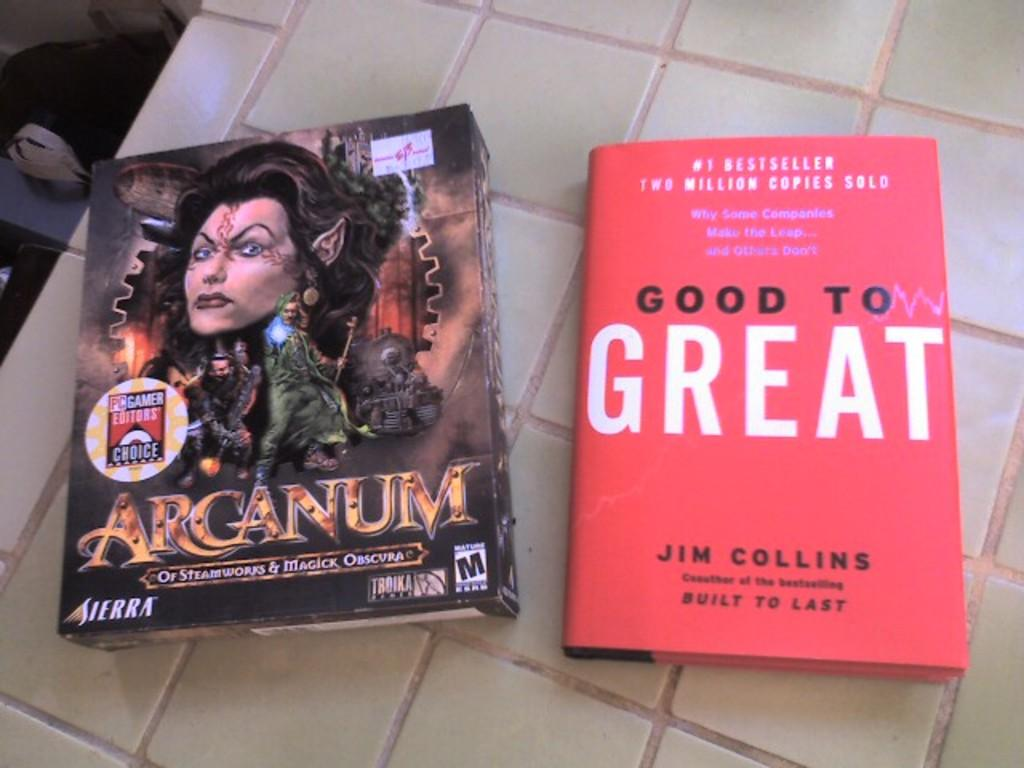<image>
Provide a brief description of the given image. The Arganum computer game box sits next to the "Good to Great" book. 